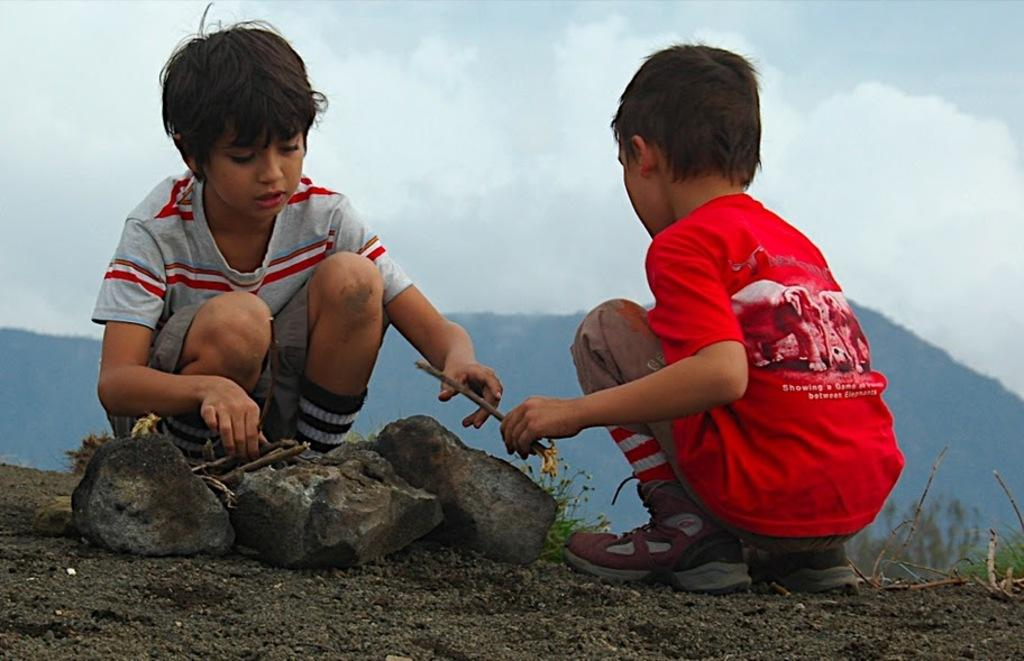How many boys are in the image? There are two boys in the image. What are the boys doing in the image? The boys are sitting and holding twigs. What can be seen at the bottom of the image? There are rocks at the bottom of the image. What is visible in the background of the image? There are hills and the sky visible in the background of the image. What type of doll is sitting next to the boys in the image? There is no doll present in the image; the boys are sitting alone. What color is the tail of the animal in the image? There is no animal with a tail present in the image. 